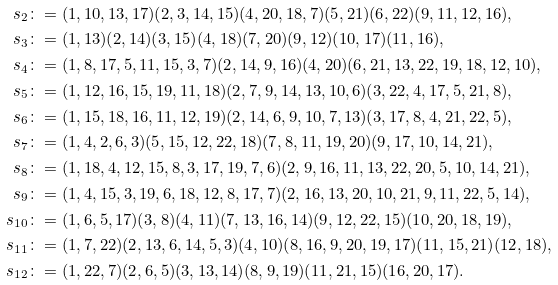Convert formula to latex. <formula><loc_0><loc_0><loc_500><loc_500>s _ { 2 } & \colon = ( 1 , 1 0 , 1 3 , 1 7 ) ( 2 , 3 , 1 4 , 1 5 ) ( 4 , 2 0 , 1 8 , 7 ) ( 5 , 2 1 ) ( 6 , 2 2 ) ( 9 , 1 1 , 1 2 , 1 6 ) , \\ s _ { 3 } & \colon = ( 1 , 1 3 ) ( 2 , 1 4 ) ( 3 , 1 5 ) ( 4 , 1 8 ) ( 7 , 2 0 ) ( 9 , 1 2 ) ( 1 0 , 1 7 ) ( 1 1 , 1 6 ) , \\ s _ { 4 } & \colon = ( 1 , 8 , 1 7 , 5 , 1 1 , 1 5 , 3 , 7 ) ( 2 , 1 4 , 9 , 1 6 ) ( 4 , 2 0 ) ( 6 , 2 1 , 1 3 , 2 2 , 1 9 , 1 8 , 1 2 , 1 0 ) , \\ s _ { 5 } & \colon = ( 1 , 1 2 , 1 6 , 1 5 , 1 9 , 1 1 , 1 8 ) ( 2 , 7 , 9 , 1 4 , 1 3 , 1 0 , 6 ) ( 3 , 2 2 , 4 , 1 7 , 5 , 2 1 , 8 ) , \\ s _ { 6 } & \colon = ( 1 , 1 5 , 1 8 , 1 6 , 1 1 , 1 2 , 1 9 ) ( 2 , 1 4 , 6 , 9 , 1 0 , 7 , 1 3 ) ( 3 , 1 7 , 8 , 4 , 2 1 , 2 2 , 5 ) , \\ s _ { 7 } & \colon = ( 1 , 4 , 2 , 6 , 3 ) ( 5 , 1 5 , 1 2 , 2 2 , 1 8 ) ( 7 , 8 , 1 1 , 1 9 , 2 0 ) ( 9 , 1 7 , 1 0 , 1 4 , 2 1 ) , \\ s _ { 8 } & \colon = ( 1 , 1 8 , 4 , 1 2 , 1 5 , 8 , 3 , 1 7 , 1 9 , 7 , 6 ) ( 2 , 9 , 1 6 , 1 1 , 1 3 , 2 2 , 2 0 , 5 , 1 0 , 1 4 , 2 1 ) , \\ s _ { 9 } & \colon = ( 1 , 4 , 1 5 , 3 , 1 9 , 6 , 1 8 , 1 2 , 8 , 1 7 , 7 ) ( 2 , 1 6 , 1 3 , 2 0 , 1 0 , 2 1 , 9 , 1 1 , 2 2 , 5 , 1 4 ) , \\ s _ { 1 0 } & \colon = ( 1 , 6 , 5 , 1 7 ) ( 3 , 8 ) ( 4 , 1 1 ) ( 7 , 1 3 , 1 6 , 1 4 ) ( 9 , 1 2 , 2 2 , 1 5 ) ( 1 0 , 2 0 , 1 8 , 1 9 ) , \\ s _ { 1 1 } & \colon = ( 1 , 7 , 2 2 ) ( 2 , 1 3 , 6 , 1 4 , 5 , 3 ) ( 4 , 1 0 ) ( 8 , 1 6 , 9 , 2 0 , 1 9 , 1 7 ) ( 1 1 , 1 5 , 2 1 ) ( 1 2 , 1 8 ) , \\ s _ { 1 2 } & \colon = ( 1 , 2 2 , 7 ) ( 2 , 6 , 5 ) ( 3 , 1 3 , 1 4 ) ( 8 , 9 , 1 9 ) ( 1 1 , 2 1 , 1 5 ) ( 1 6 , 2 0 , 1 7 ) .</formula> 